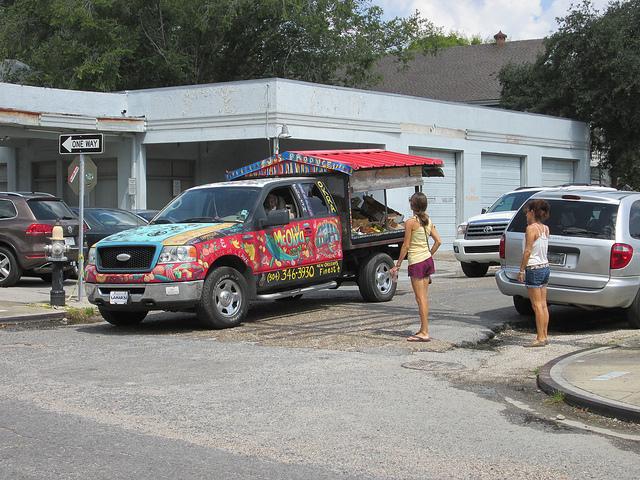What is the truck selling?
Keep it brief. Food. What color are the garage doors?
Concise answer only. White. What color shorts is she wearing?
Keep it brief. Purple. 